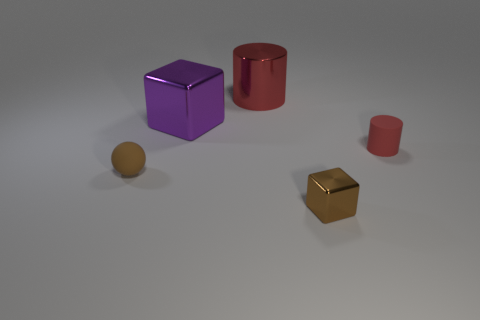Add 1 small brown metal cubes. How many objects exist? 6 Subtract all cylinders. How many objects are left? 3 Subtract 0 yellow cylinders. How many objects are left? 5 Subtract all shiny cubes. Subtract all small red matte things. How many objects are left? 2 Add 5 small rubber spheres. How many small rubber spheres are left? 6 Add 3 large purple matte balls. How many large purple matte balls exist? 3 